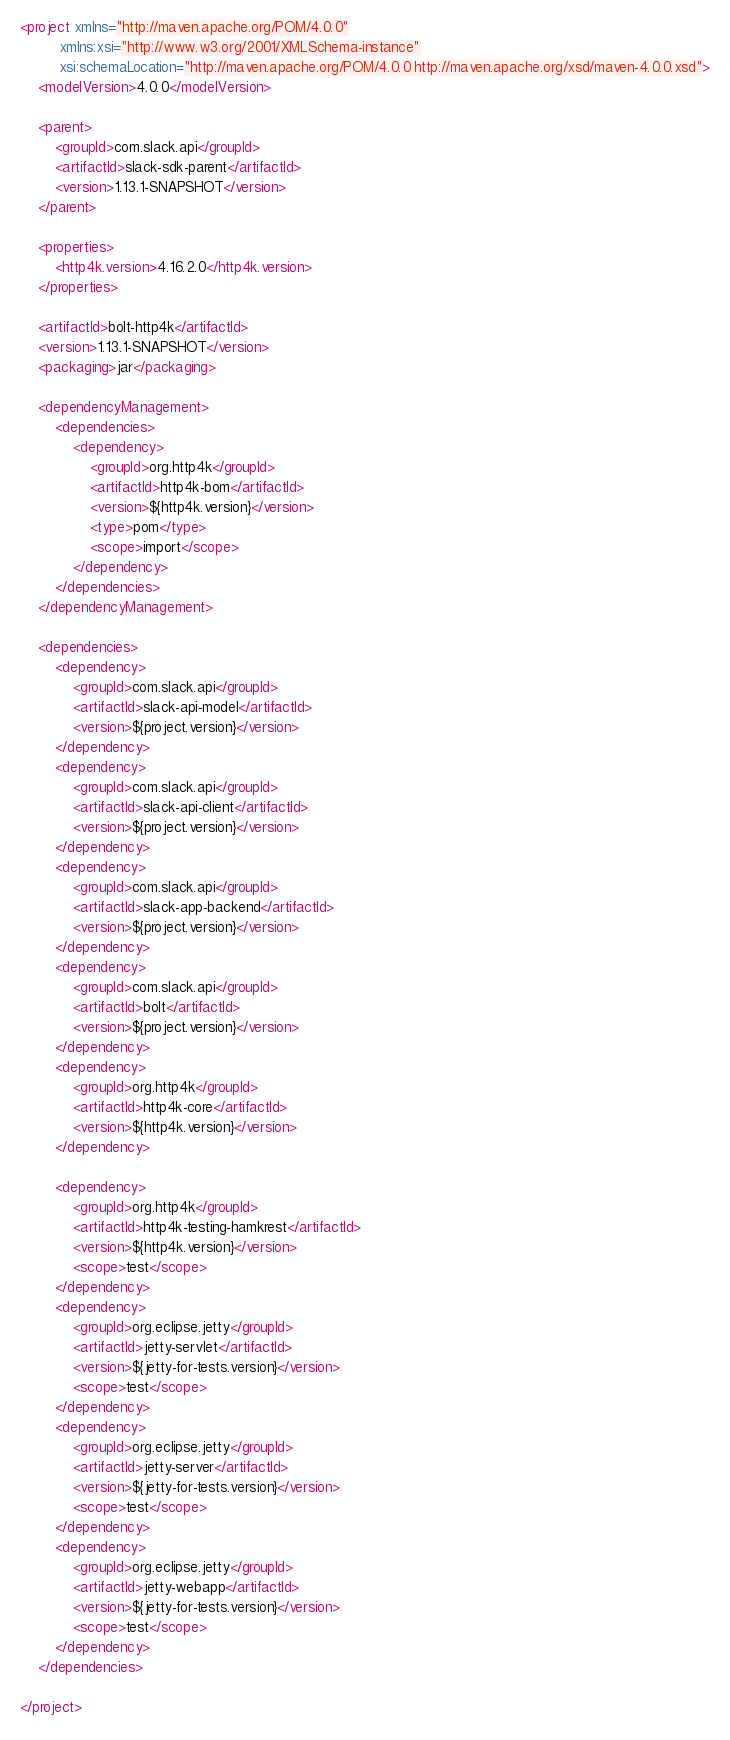<code> <loc_0><loc_0><loc_500><loc_500><_XML_><project xmlns="http://maven.apache.org/POM/4.0.0"
         xmlns:xsi="http://www.w3.org/2001/XMLSchema-instance"
         xsi:schemaLocation="http://maven.apache.org/POM/4.0.0 http://maven.apache.org/xsd/maven-4.0.0.xsd">
    <modelVersion>4.0.0</modelVersion>

    <parent>
        <groupId>com.slack.api</groupId>
        <artifactId>slack-sdk-parent</artifactId>
        <version>1.13.1-SNAPSHOT</version>
    </parent>

    <properties>
        <http4k.version>4.16.2.0</http4k.version>
    </properties>

    <artifactId>bolt-http4k</artifactId>
    <version>1.13.1-SNAPSHOT</version>
    <packaging>jar</packaging>

    <dependencyManagement>
        <dependencies>
            <dependency>
                <groupId>org.http4k</groupId>
                <artifactId>http4k-bom</artifactId>
                <version>${http4k.version}</version>
                <type>pom</type>
                <scope>import</scope>
            </dependency>
        </dependencies>
    </dependencyManagement>

    <dependencies>
        <dependency>
            <groupId>com.slack.api</groupId>
            <artifactId>slack-api-model</artifactId>
            <version>${project.version}</version>
        </dependency>
        <dependency>
            <groupId>com.slack.api</groupId>
            <artifactId>slack-api-client</artifactId>
            <version>${project.version}</version>
        </dependency>
        <dependency>
            <groupId>com.slack.api</groupId>
            <artifactId>slack-app-backend</artifactId>
            <version>${project.version}</version>
        </dependency>
        <dependency>
            <groupId>com.slack.api</groupId>
            <artifactId>bolt</artifactId>
            <version>${project.version}</version>
        </dependency>
        <dependency>
            <groupId>org.http4k</groupId>
            <artifactId>http4k-core</artifactId>
            <version>${http4k.version}</version>
        </dependency>

        <dependency>
            <groupId>org.http4k</groupId>
            <artifactId>http4k-testing-hamkrest</artifactId>
            <version>${http4k.version}</version>
            <scope>test</scope>
        </dependency>
        <dependency>
            <groupId>org.eclipse.jetty</groupId>
            <artifactId>jetty-servlet</artifactId>
            <version>${jetty-for-tests.version}</version>
            <scope>test</scope>
        </dependency>
        <dependency>
            <groupId>org.eclipse.jetty</groupId>
            <artifactId>jetty-server</artifactId>
            <version>${jetty-for-tests.version}</version>
            <scope>test</scope>
        </dependency>
        <dependency>
            <groupId>org.eclipse.jetty</groupId>
            <artifactId>jetty-webapp</artifactId>
            <version>${jetty-for-tests.version}</version>
            <scope>test</scope>
        </dependency>
    </dependencies>

</project>
</code> 